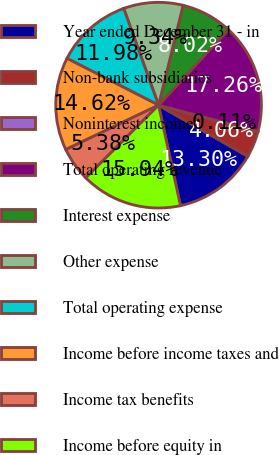<chart> <loc_0><loc_0><loc_500><loc_500><pie_chart><fcel>Year ended December 31 - in<fcel>Non-bank subsidiaries<fcel>Noninterest income<fcel>Total operating revenue<fcel>Interest expense<fcel>Other expense<fcel>Total operating expense<fcel>Income before income taxes and<fcel>Income tax benefits<fcel>Income before equity in<nl><fcel>13.3%<fcel>4.06%<fcel>0.11%<fcel>17.26%<fcel>8.02%<fcel>9.34%<fcel>11.98%<fcel>14.62%<fcel>5.38%<fcel>15.94%<nl></chart> 